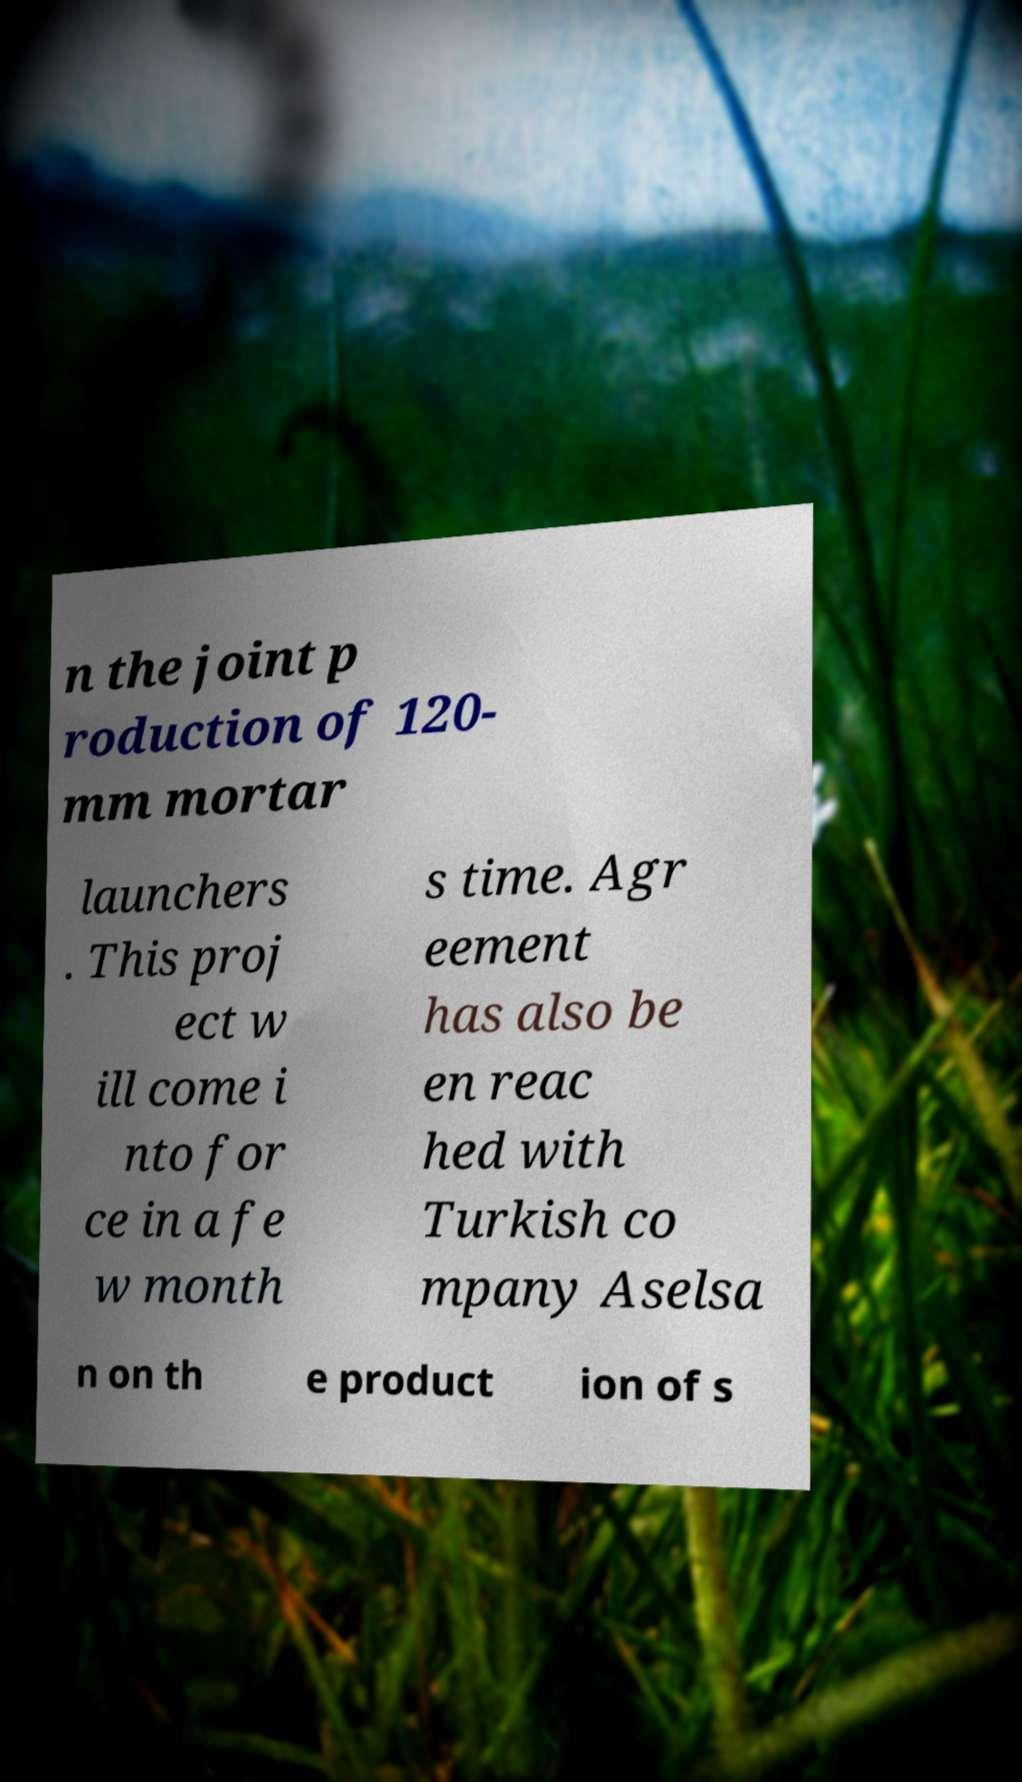Could you assist in decoding the text presented in this image and type it out clearly? n the joint p roduction of 120- mm mortar launchers . This proj ect w ill come i nto for ce in a fe w month s time. Agr eement has also be en reac hed with Turkish co mpany Aselsa n on th e product ion of s 